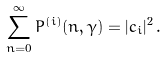Convert formula to latex. <formula><loc_0><loc_0><loc_500><loc_500>\sum _ { n = 0 } ^ { \infty } P ^ { ( i ) } ( n , \gamma ) = | c _ { i } | ^ { 2 } \, .</formula> 